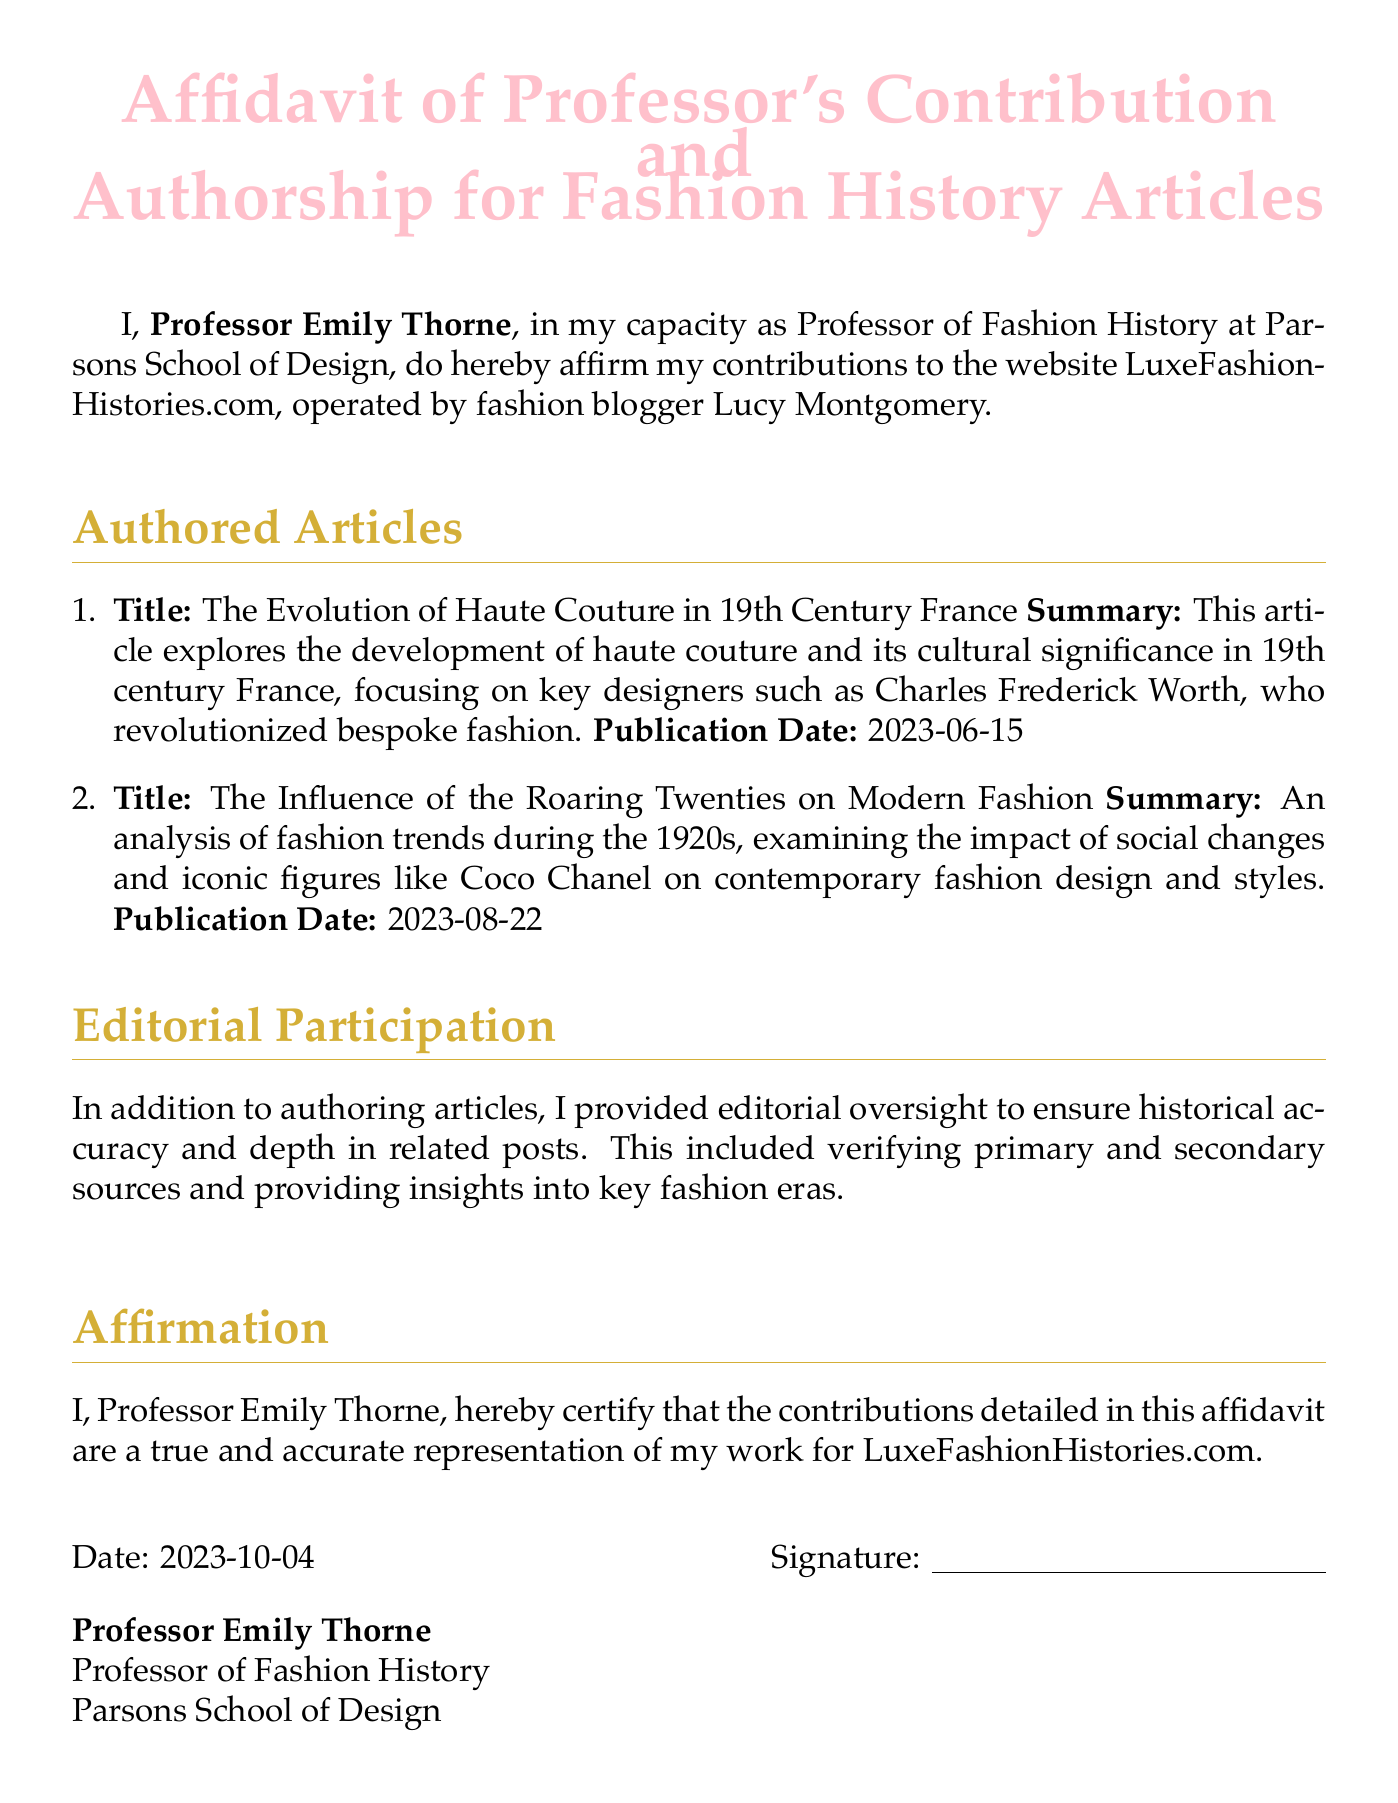What is the name of the professor? The professor's name is mentioned at the beginning of the document as Professor Emily Thorne.
Answer: Professor Emily Thorne What is the title of the first article? The title of the first article is explicitly listed in the document.
Answer: The Evolution of Haute Couture in 19th Century France What is the publication date of the second article? The publication date of the second article is clearly stated in the enumeration within the document.
Answer: 2023-08-22 How many articles has the professor authored? The number of articles is determined by counting the items listed in the authored articles section.
Answer: 2 What institution does the professor teach at? The institution where the professor works is provided in the introductory line of the document.
Answer: Parsons School of Design What additional role did the professor have besides authorship? The additional role of the professor is mentioned in the section outlining contributions to the website.
Answer: Editorial oversight What is the affirmation statement date? The affirmation statement date is given at the bottom of the document just before the signature line.
Answer: 2023-10-04 What color is used for section titles? The document specifies the color used for section titles in the header setup.
Answer: Fashion gold 